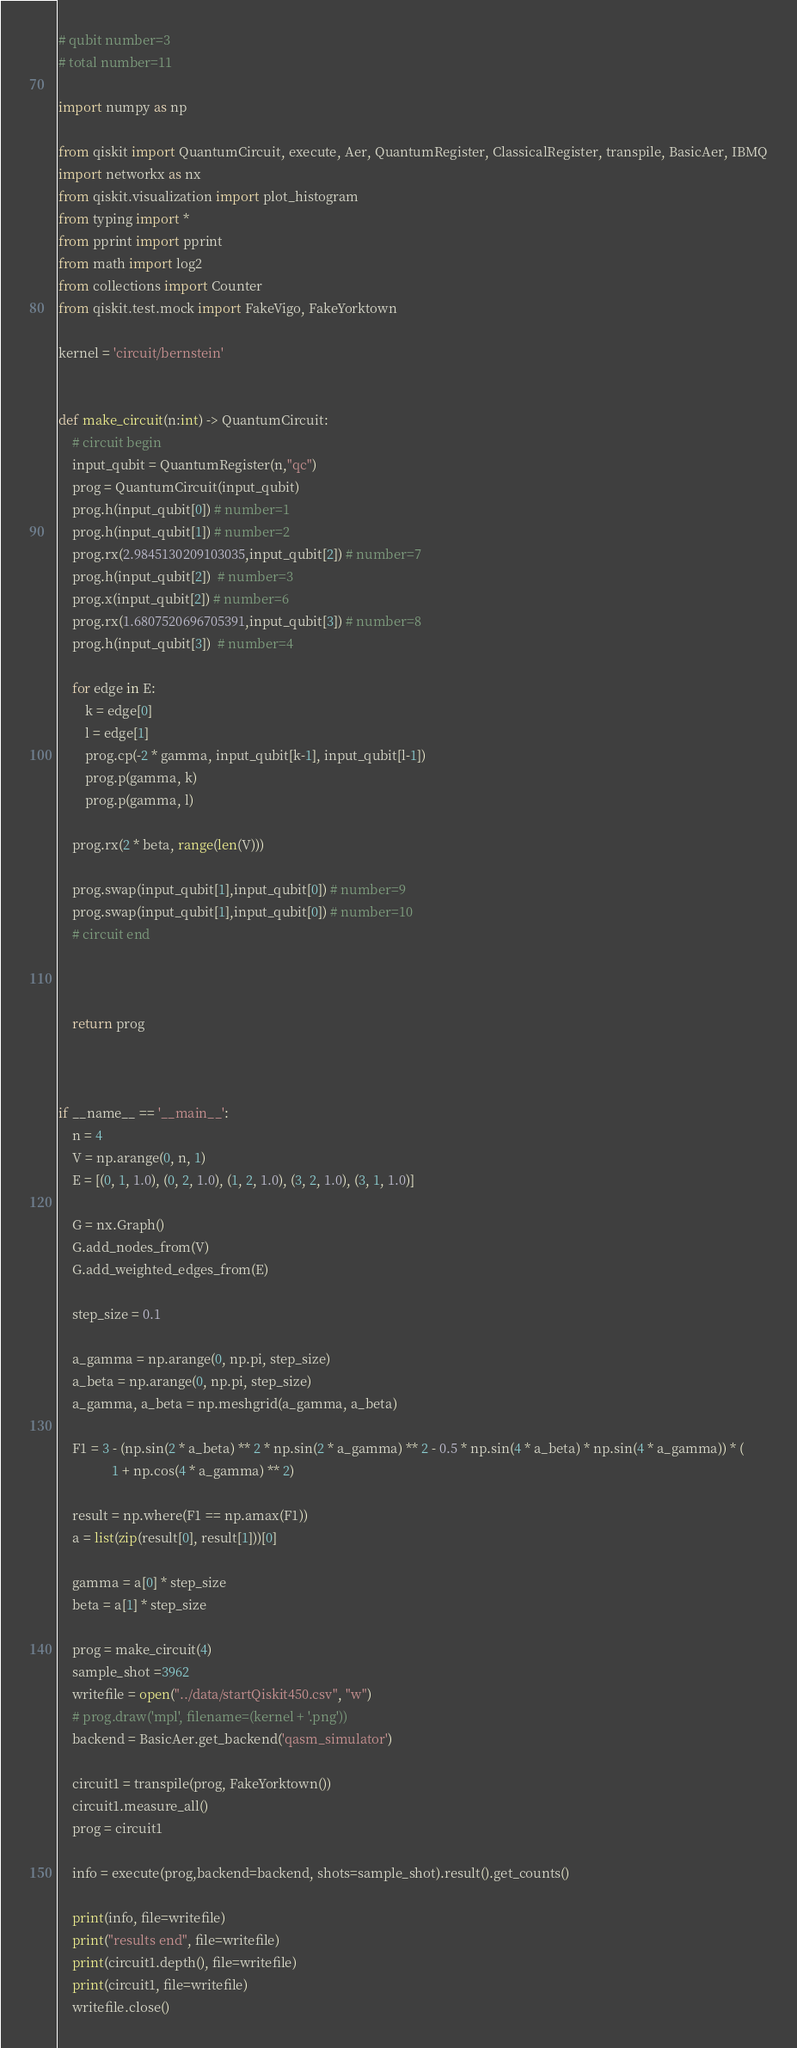<code> <loc_0><loc_0><loc_500><loc_500><_Python_># qubit number=3
# total number=11

import numpy as np

from qiskit import QuantumCircuit, execute, Aer, QuantumRegister, ClassicalRegister, transpile, BasicAer, IBMQ
import networkx as nx
from qiskit.visualization import plot_histogram
from typing import *
from pprint import pprint
from math import log2
from collections import Counter
from qiskit.test.mock import FakeVigo, FakeYorktown

kernel = 'circuit/bernstein'


def make_circuit(n:int) -> QuantumCircuit:
    # circuit begin
    input_qubit = QuantumRegister(n,"qc")
    prog = QuantumCircuit(input_qubit)
    prog.h(input_qubit[0]) # number=1
    prog.h(input_qubit[1]) # number=2
    prog.rx(2.9845130209103035,input_qubit[2]) # number=7
    prog.h(input_qubit[2])  # number=3
    prog.x(input_qubit[2]) # number=6
    prog.rx(1.6807520696705391,input_qubit[3]) # number=8
    prog.h(input_qubit[3])  # number=4

    for edge in E:
        k = edge[0]
        l = edge[1]
        prog.cp(-2 * gamma, input_qubit[k-1], input_qubit[l-1])
        prog.p(gamma, k)
        prog.p(gamma, l)

    prog.rx(2 * beta, range(len(V)))

    prog.swap(input_qubit[1],input_qubit[0]) # number=9
    prog.swap(input_qubit[1],input_qubit[0]) # number=10
    # circuit end



    return prog



if __name__ == '__main__':
    n = 4
    V = np.arange(0, n, 1)
    E = [(0, 1, 1.0), (0, 2, 1.0), (1, 2, 1.0), (3, 2, 1.0), (3, 1, 1.0)]

    G = nx.Graph()
    G.add_nodes_from(V)
    G.add_weighted_edges_from(E)

    step_size = 0.1

    a_gamma = np.arange(0, np.pi, step_size)
    a_beta = np.arange(0, np.pi, step_size)
    a_gamma, a_beta = np.meshgrid(a_gamma, a_beta)

    F1 = 3 - (np.sin(2 * a_beta) ** 2 * np.sin(2 * a_gamma) ** 2 - 0.5 * np.sin(4 * a_beta) * np.sin(4 * a_gamma)) * (
                1 + np.cos(4 * a_gamma) ** 2)

    result = np.where(F1 == np.amax(F1))
    a = list(zip(result[0], result[1]))[0]

    gamma = a[0] * step_size
    beta = a[1] * step_size

    prog = make_circuit(4)
    sample_shot =3962
    writefile = open("../data/startQiskit450.csv", "w")
    # prog.draw('mpl', filename=(kernel + '.png'))
    backend = BasicAer.get_backend('qasm_simulator')

    circuit1 = transpile(prog, FakeYorktown())
    circuit1.measure_all()
    prog = circuit1

    info = execute(prog,backend=backend, shots=sample_shot).result().get_counts()

    print(info, file=writefile)
    print("results end", file=writefile)
    print(circuit1.depth(), file=writefile)
    print(circuit1, file=writefile)
    writefile.close()
</code> 